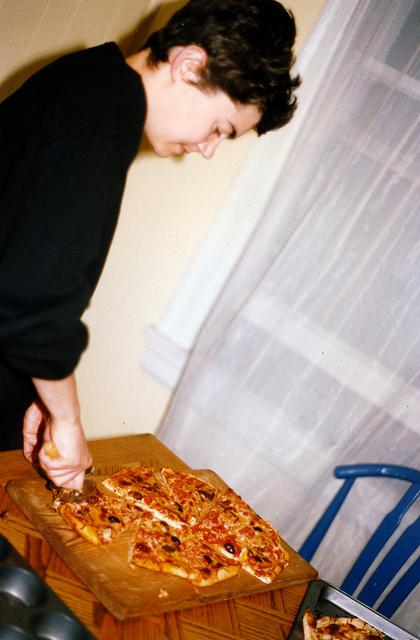Is this in a dining room?
Keep it brief. Yes. What color is the chair?
Short answer required. Blue. What is he getting?
Answer briefly. Pizza. 